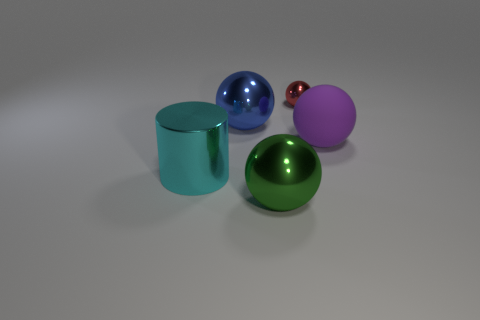Are there any other things that have the same material as the big purple ball?
Provide a succinct answer. No. How many other things are the same color as the shiny cylinder?
Provide a short and direct response. 0. What is the red ball made of?
Offer a very short reply. Metal. There is a red metallic thing that is on the right side of the shiny cylinder; is it the same size as the big cyan cylinder?
Your response must be concise. No. Is there any other thing that is the same size as the metal cylinder?
Your answer should be very brief. Yes. There is another rubber thing that is the same shape as the red thing; what is its size?
Keep it short and to the point. Large. Are there an equal number of large cyan metal cylinders right of the rubber object and cyan cylinders that are to the right of the blue object?
Your answer should be compact. Yes. There is a shiny sphere in front of the big rubber sphere; how big is it?
Offer a very short reply. Large. Do the matte thing and the small metallic object have the same color?
Keep it short and to the point. No. Is there any other thing that has the same shape as the large green object?
Your answer should be compact. Yes. 